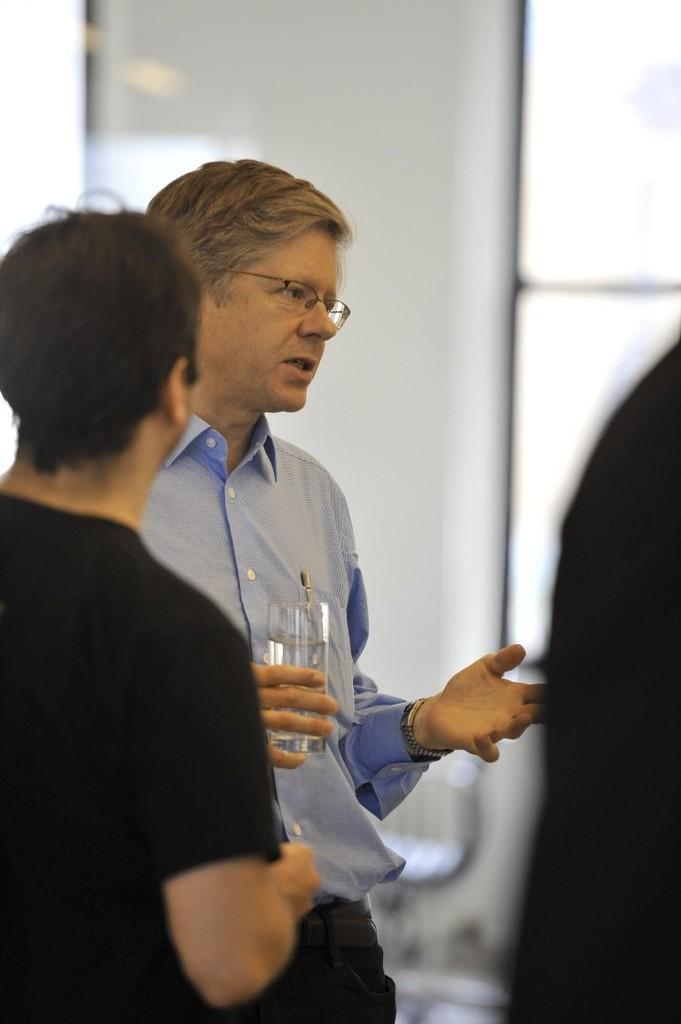Who can be seen in the image? There are people in the image. Can you describe the man in the middle of the image? The man in the middle of the image is wearing spectacles. What is the man holding in the image? The man is holding a glass. What type of door can be seen in the image? There is no door present in the image. What is the man using to cut the line in the image? There is no line or knife present in the image. 